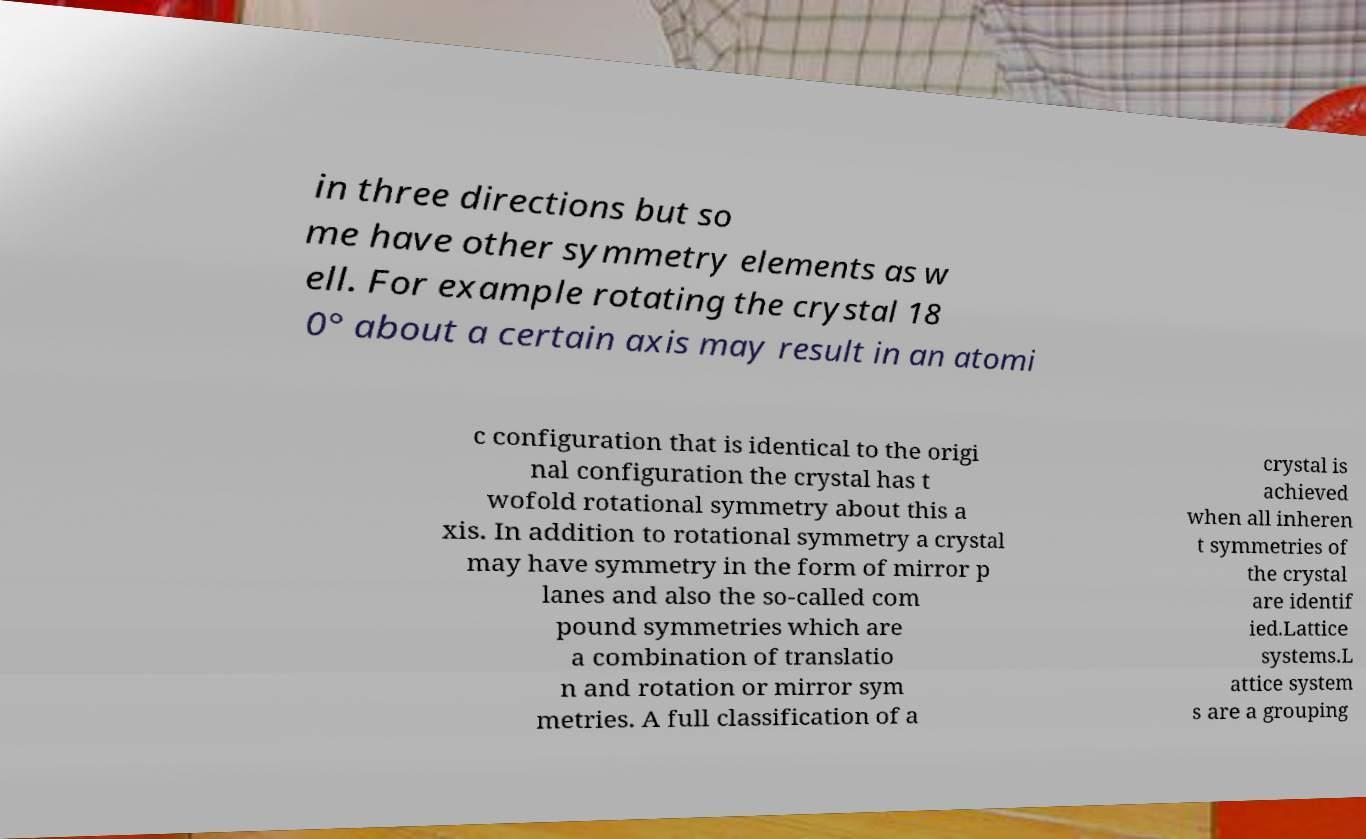Could you assist in decoding the text presented in this image and type it out clearly? in three directions but so me have other symmetry elements as w ell. For example rotating the crystal 18 0° about a certain axis may result in an atomi c configuration that is identical to the origi nal configuration the crystal has t wofold rotational symmetry about this a xis. In addition to rotational symmetry a crystal may have symmetry in the form of mirror p lanes and also the so-called com pound symmetries which are a combination of translatio n and rotation or mirror sym metries. A full classification of a crystal is achieved when all inheren t symmetries of the crystal are identif ied.Lattice systems.L attice system s are a grouping 